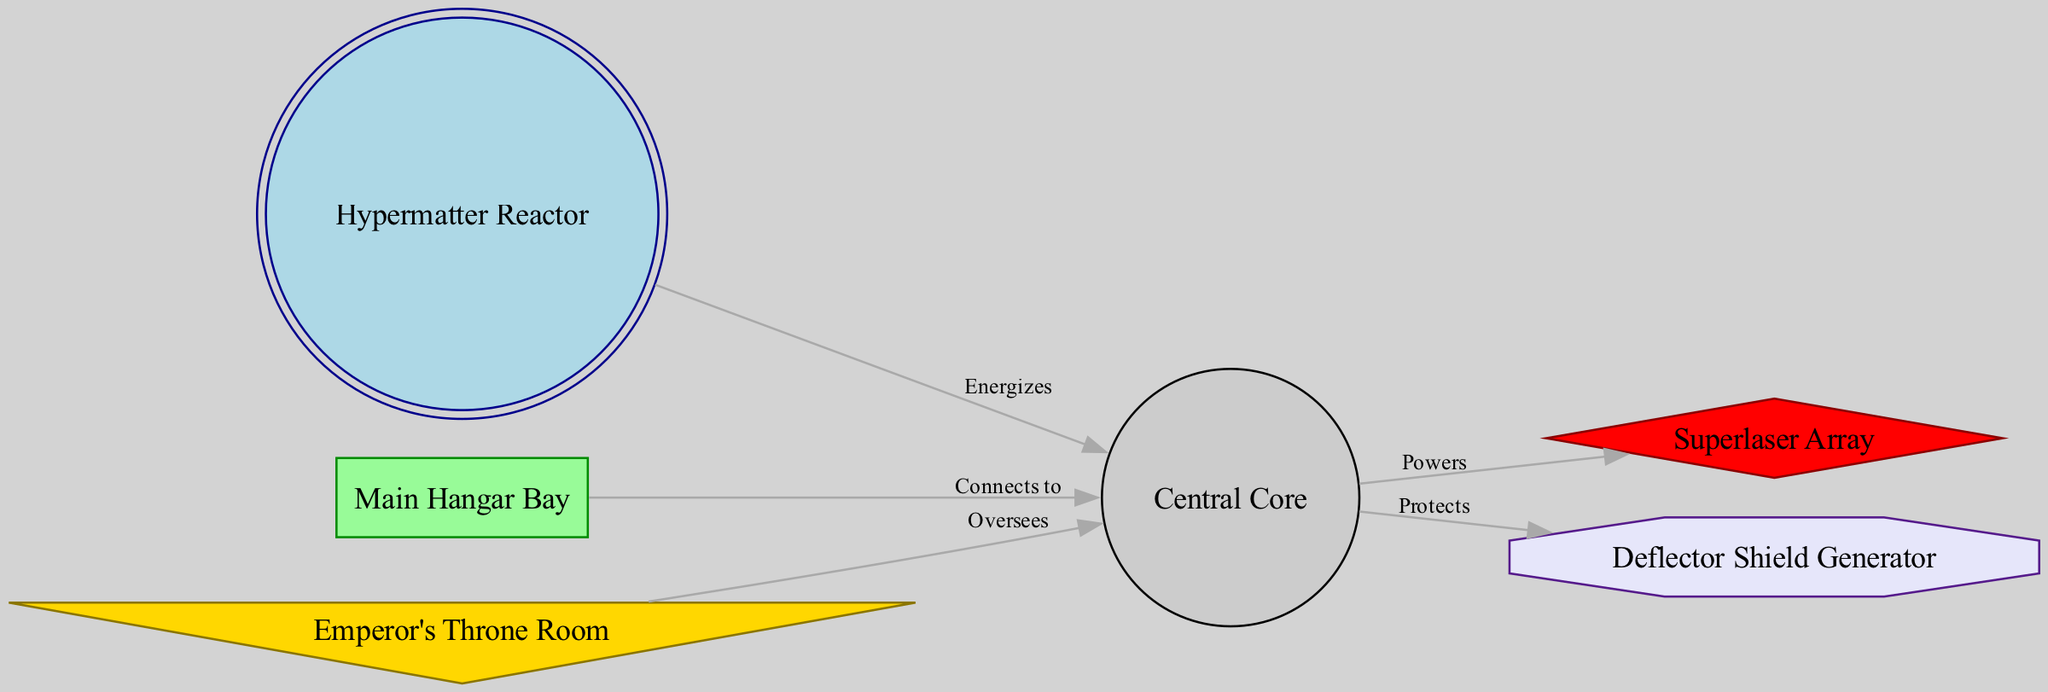What is the central component of the Death Star? The central component is labeled as "Central Core" in the diagram. This node serves as the main hub from which other systems operate or connect.
Answer: Central Core How many main systems are displayed in the diagram? The diagram features six main systems as indicated by the six nodes: Central Core, Superlaser Array, Hypermatter Reactor, Main Hangar Bay, Deflector Shield Generator, and Emperor's Throne Room.
Answer: Six Which system connects to the Deflector Shield Generator? The Deflector Shield Generator has a direct relationship with the Central Core, as indicated by the "Protects" label on the edge connecting them.
Answer: Central Core What powers the Superlaser Array? The diagram shows that the Superlaser Array is powered by the Central Core, depicted by the "Powers" label on the edge from Central Core to Superlaser Array.
Answer: Central Core From which system does the Hypermatter Reactor draw energy? The Hypermatter Reactor energizes the Central Core, indicated by the "Energizes" label on the edge connecting the two systems.
Answer: Central Core What is the relationship between the Emperor's Throne Room and the Central Core? The Emperor's Throne Room oversees the Central Core, as illustrated by the edge connecting them labeled "Oversees." This indicates a supervisory position.
Answer: Oversees Identify the system that connects both the Central Core and the Main Hangar Bay. The diagram states that the Main Hangar Bay connects to the Central Core directly, as indicated by the "Connects to" label on the edge between these two nodes.
Answer: Central Core How many edges are present in the diagram? There are five edges illustrated in the diagram, representing the relationships between the six systems. Each edge shows a connection or action between two nodes.
Answer: Five What is the shape of the node representing the Superlaser Array? The Superlaser Array is depicted as a diamond shape in the diagram, which differentiates it visually from the other components.
Answer: Diamond What generates protection for the Death Star? The Deflector Shield Generator provides protection as stated in the diagram where it connects back to the Central Core for protective functions.
Answer: Deflector Shield Generator 